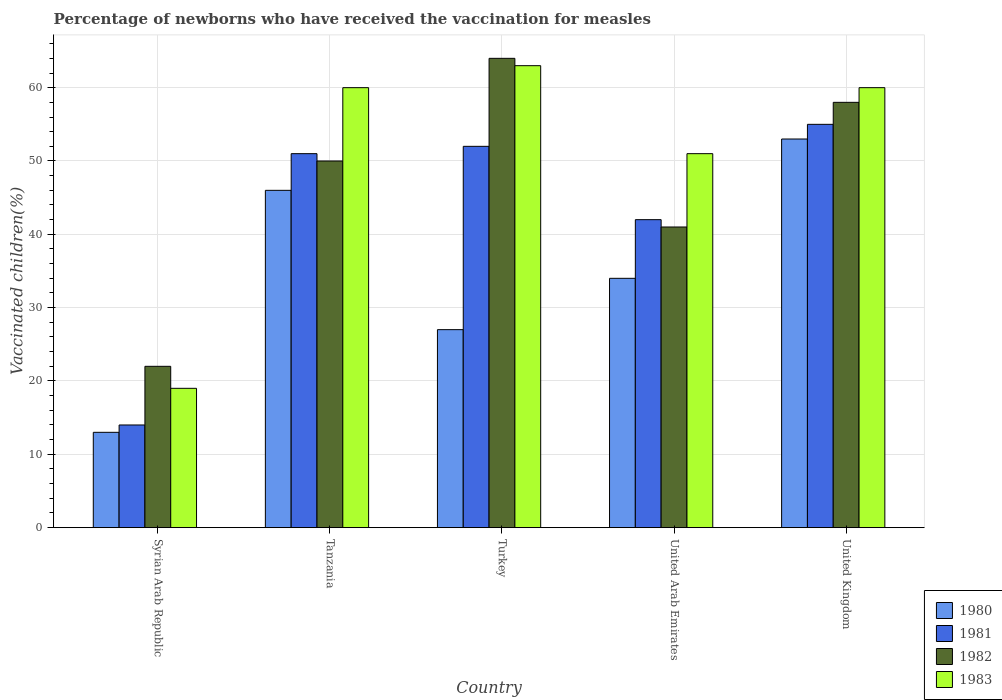How many groups of bars are there?
Make the answer very short. 5. Are the number of bars on each tick of the X-axis equal?
Provide a short and direct response. Yes. How many bars are there on the 3rd tick from the left?
Provide a succinct answer. 4. How many bars are there on the 4th tick from the right?
Your answer should be very brief. 4. What is the label of the 2nd group of bars from the left?
Your answer should be very brief. Tanzania. What is the percentage of vaccinated children in 1982 in Tanzania?
Offer a very short reply. 50. Across all countries, what is the maximum percentage of vaccinated children in 1983?
Keep it short and to the point. 63. Across all countries, what is the minimum percentage of vaccinated children in 1983?
Ensure brevity in your answer.  19. In which country was the percentage of vaccinated children in 1980 minimum?
Offer a very short reply. Syrian Arab Republic. What is the total percentage of vaccinated children in 1983 in the graph?
Ensure brevity in your answer.  253. What is the difference between the percentage of vaccinated children in 1981 in Tanzania and that in Turkey?
Your response must be concise. -1. What is the average percentage of vaccinated children in 1980 per country?
Ensure brevity in your answer.  34.6. What is the difference between the percentage of vaccinated children of/in 1983 and percentage of vaccinated children of/in 1980 in United Arab Emirates?
Offer a very short reply. 17. What is the ratio of the percentage of vaccinated children in 1981 in Syrian Arab Republic to that in Turkey?
Make the answer very short. 0.27. What is the difference between the highest and the lowest percentage of vaccinated children in 1983?
Provide a succinct answer. 44. Is the sum of the percentage of vaccinated children in 1982 in Tanzania and Turkey greater than the maximum percentage of vaccinated children in 1983 across all countries?
Provide a succinct answer. Yes. Is it the case that in every country, the sum of the percentage of vaccinated children in 1982 and percentage of vaccinated children in 1980 is greater than the sum of percentage of vaccinated children in 1981 and percentage of vaccinated children in 1983?
Ensure brevity in your answer.  No. What does the 2nd bar from the left in United Kingdom represents?
Offer a very short reply. 1981. What does the 2nd bar from the right in United Arab Emirates represents?
Your answer should be compact. 1982. Is it the case that in every country, the sum of the percentage of vaccinated children in 1983 and percentage of vaccinated children in 1982 is greater than the percentage of vaccinated children in 1981?
Offer a very short reply. Yes. Are all the bars in the graph horizontal?
Make the answer very short. No. Does the graph contain grids?
Provide a succinct answer. Yes. Where does the legend appear in the graph?
Your answer should be very brief. Bottom right. How many legend labels are there?
Your answer should be very brief. 4. What is the title of the graph?
Provide a short and direct response. Percentage of newborns who have received the vaccination for measles. Does "1960" appear as one of the legend labels in the graph?
Give a very brief answer. No. What is the label or title of the X-axis?
Your response must be concise. Country. What is the label or title of the Y-axis?
Make the answer very short. Vaccinated children(%). What is the Vaccinated children(%) of 1981 in Tanzania?
Offer a terse response. 51. What is the Vaccinated children(%) of 1982 in Tanzania?
Offer a terse response. 50. What is the Vaccinated children(%) in 1980 in Turkey?
Your response must be concise. 27. What is the Vaccinated children(%) of 1982 in Turkey?
Ensure brevity in your answer.  64. What is the Vaccinated children(%) of 1983 in Turkey?
Keep it short and to the point. 63. What is the Vaccinated children(%) of 1980 in United Arab Emirates?
Provide a short and direct response. 34. What is the Vaccinated children(%) in 1981 in United Arab Emirates?
Your answer should be compact. 42. What is the Vaccinated children(%) in 1980 in United Kingdom?
Offer a very short reply. 53. Across all countries, what is the maximum Vaccinated children(%) in 1980?
Keep it short and to the point. 53. Across all countries, what is the maximum Vaccinated children(%) of 1981?
Make the answer very short. 55. Across all countries, what is the maximum Vaccinated children(%) of 1982?
Your answer should be very brief. 64. Across all countries, what is the maximum Vaccinated children(%) in 1983?
Keep it short and to the point. 63. Across all countries, what is the minimum Vaccinated children(%) in 1982?
Your answer should be compact. 22. Across all countries, what is the minimum Vaccinated children(%) of 1983?
Offer a very short reply. 19. What is the total Vaccinated children(%) in 1980 in the graph?
Keep it short and to the point. 173. What is the total Vaccinated children(%) in 1981 in the graph?
Keep it short and to the point. 214. What is the total Vaccinated children(%) of 1982 in the graph?
Offer a terse response. 235. What is the total Vaccinated children(%) in 1983 in the graph?
Your answer should be compact. 253. What is the difference between the Vaccinated children(%) in 1980 in Syrian Arab Republic and that in Tanzania?
Make the answer very short. -33. What is the difference between the Vaccinated children(%) of 1981 in Syrian Arab Republic and that in Tanzania?
Your answer should be compact. -37. What is the difference between the Vaccinated children(%) of 1982 in Syrian Arab Republic and that in Tanzania?
Give a very brief answer. -28. What is the difference between the Vaccinated children(%) of 1983 in Syrian Arab Republic and that in Tanzania?
Keep it short and to the point. -41. What is the difference between the Vaccinated children(%) of 1980 in Syrian Arab Republic and that in Turkey?
Provide a succinct answer. -14. What is the difference between the Vaccinated children(%) of 1981 in Syrian Arab Republic and that in Turkey?
Make the answer very short. -38. What is the difference between the Vaccinated children(%) of 1982 in Syrian Arab Republic and that in Turkey?
Your answer should be compact. -42. What is the difference between the Vaccinated children(%) in 1983 in Syrian Arab Republic and that in Turkey?
Keep it short and to the point. -44. What is the difference between the Vaccinated children(%) in 1980 in Syrian Arab Republic and that in United Arab Emirates?
Offer a very short reply. -21. What is the difference between the Vaccinated children(%) in 1982 in Syrian Arab Republic and that in United Arab Emirates?
Give a very brief answer. -19. What is the difference between the Vaccinated children(%) in 1983 in Syrian Arab Republic and that in United Arab Emirates?
Provide a short and direct response. -32. What is the difference between the Vaccinated children(%) in 1980 in Syrian Arab Republic and that in United Kingdom?
Give a very brief answer. -40. What is the difference between the Vaccinated children(%) of 1981 in Syrian Arab Republic and that in United Kingdom?
Offer a terse response. -41. What is the difference between the Vaccinated children(%) of 1982 in Syrian Arab Republic and that in United Kingdom?
Offer a terse response. -36. What is the difference between the Vaccinated children(%) of 1983 in Syrian Arab Republic and that in United Kingdom?
Ensure brevity in your answer.  -41. What is the difference between the Vaccinated children(%) in 1980 in Tanzania and that in Turkey?
Keep it short and to the point. 19. What is the difference between the Vaccinated children(%) of 1981 in Tanzania and that in Turkey?
Provide a succinct answer. -1. What is the difference between the Vaccinated children(%) of 1982 in Tanzania and that in Turkey?
Provide a succinct answer. -14. What is the difference between the Vaccinated children(%) in 1983 in Tanzania and that in Turkey?
Make the answer very short. -3. What is the difference between the Vaccinated children(%) in 1982 in Tanzania and that in United Arab Emirates?
Give a very brief answer. 9. What is the difference between the Vaccinated children(%) in 1983 in Tanzania and that in United Arab Emirates?
Your answer should be very brief. 9. What is the difference between the Vaccinated children(%) of 1981 in Tanzania and that in United Kingdom?
Give a very brief answer. -4. What is the difference between the Vaccinated children(%) in 1983 in Tanzania and that in United Kingdom?
Ensure brevity in your answer.  0. What is the difference between the Vaccinated children(%) in 1983 in Turkey and that in United Arab Emirates?
Your response must be concise. 12. What is the difference between the Vaccinated children(%) in 1980 in United Arab Emirates and that in United Kingdom?
Provide a short and direct response. -19. What is the difference between the Vaccinated children(%) in 1981 in United Arab Emirates and that in United Kingdom?
Your response must be concise. -13. What is the difference between the Vaccinated children(%) of 1982 in United Arab Emirates and that in United Kingdom?
Your answer should be compact. -17. What is the difference between the Vaccinated children(%) of 1980 in Syrian Arab Republic and the Vaccinated children(%) of 1981 in Tanzania?
Make the answer very short. -38. What is the difference between the Vaccinated children(%) of 1980 in Syrian Arab Republic and the Vaccinated children(%) of 1982 in Tanzania?
Your response must be concise. -37. What is the difference between the Vaccinated children(%) in 1980 in Syrian Arab Republic and the Vaccinated children(%) in 1983 in Tanzania?
Offer a very short reply. -47. What is the difference between the Vaccinated children(%) in 1981 in Syrian Arab Republic and the Vaccinated children(%) in 1982 in Tanzania?
Ensure brevity in your answer.  -36. What is the difference between the Vaccinated children(%) in 1981 in Syrian Arab Republic and the Vaccinated children(%) in 1983 in Tanzania?
Provide a succinct answer. -46. What is the difference between the Vaccinated children(%) in 1982 in Syrian Arab Republic and the Vaccinated children(%) in 1983 in Tanzania?
Keep it short and to the point. -38. What is the difference between the Vaccinated children(%) in 1980 in Syrian Arab Republic and the Vaccinated children(%) in 1981 in Turkey?
Provide a succinct answer. -39. What is the difference between the Vaccinated children(%) of 1980 in Syrian Arab Republic and the Vaccinated children(%) of 1982 in Turkey?
Keep it short and to the point. -51. What is the difference between the Vaccinated children(%) in 1981 in Syrian Arab Republic and the Vaccinated children(%) in 1982 in Turkey?
Keep it short and to the point. -50. What is the difference between the Vaccinated children(%) in 1981 in Syrian Arab Republic and the Vaccinated children(%) in 1983 in Turkey?
Provide a short and direct response. -49. What is the difference between the Vaccinated children(%) in 1982 in Syrian Arab Republic and the Vaccinated children(%) in 1983 in Turkey?
Your response must be concise. -41. What is the difference between the Vaccinated children(%) in 1980 in Syrian Arab Republic and the Vaccinated children(%) in 1981 in United Arab Emirates?
Your answer should be very brief. -29. What is the difference between the Vaccinated children(%) in 1980 in Syrian Arab Republic and the Vaccinated children(%) in 1983 in United Arab Emirates?
Ensure brevity in your answer.  -38. What is the difference between the Vaccinated children(%) in 1981 in Syrian Arab Republic and the Vaccinated children(%) in 1983 in United Arab Emirates?
Provide a short and direct response. -37. What is the difference between the Vaccinated children(%) in 1982 in Syrian Arab Republic and the Vaccinated children(%) in 1983 in United Arab Emirates?
Offer a very short reply. -29. What is the difference between the Vaccinated children(%) in 1980 in Syrian Arab Republic and the Vaccinated children(%) in 1981 in United Kingdom?
Offer a very short reply. -42. What is the difference between the Vaccinated children(%) of 1980 in Syrian Arab Republic and the Vaccinated children(%) of 1982 in United Kingdom?
Keep it short and to the point. -45. What is the difference between the Vaccinated children(%) in 1980 in Syrian Arab Republic and the Vaccinated children(%) in 1983 in United Kingdom?
Keep it short and to the point. -47. What is the difference between the Vaccinated children(%) of 1981 in Syrian Arab Republic and the Vaccinated children(%) of 1982 in United Kingdom?
Offer a very short reply. -44. What is the difference between the Vaccinated children(%) of 1981 in Syrian Arab Republic and the Vaccinated children(%) of 1983 in United Kingdom?
Make the answer very short. -46. What is the difference between the Vaccinated children(%) in 1982 in Syrian Arab Republic and the Vaccinated children(%) in 1983 in United Kingdom?
Offer a terse response. -38. What is the difference between the Vaccinated children(%) of 1980 in Tanzania and the Vaccinated children(%) of 1982 in Turkey?
Your answer should be very brief. -18. What is the difference between the Vaccinated children(%) of 1980 in Tanzania and the Vaccinated children(%) of 1983 in Turkey?
Your response must be concise. -17. What is the difference between the Vaccinated children(%) of 1982 in Tanzania and the Vaccinated children(%) of 1983 in Turkey?
Your response must be concise. -13. What is the difference between the Vaccinated children(%) in 1980 in Tanzania and the Vaccinated children(%) in 1982 in United Arab Emirates?
Make the answer very short. 5. What is the difference between the Vaccinated children(%) of 1981 in Tanzania and the Vaccinated children(%) of 1982 in United Arab Emirates?
Give a very brief answer. 10. What is the difference between the Vaccinated children(%) of 1981 in Tanzania and the Vaccinated children(%) of 1983 in United Arab Emirates?
Make the answer very short. 0. What is the difference between the Vaccinated children(%) in 1982 in Tanzania and the Vaccinated children(%) in 1983 in United Arab Emirates?
Your answer should be very brief. -1. What is the difference between the Vaccinated children(%) in 1980 in Tanzania and the Vaccinated children(%) in 1981 in United Kingdom?
Offer a very short reply. -9. What is the difference between the Vaccinated children(%) of 1980 in Tanzania and the Vaccinated children(%) of 1982 in United Kingdom?
Provide a short and direct response. -12. What is the difference between the Vaccinated children(%) in 1980 in Turkey and the Vaccinated children(%) in 1981 in United Arab Emirates?
Provide a short and direct response. -15. What is the difference between the Vaccinated children(%) in 1980 in Turkey and the Vaccinated children(%) in 1983 in United Arab Emirates?
Your answer should be compact. -24. What is the difference between the Vaccinated children(%) in 1981 in Turkey and the Vaccinated children(%) in 1983 in United Arab Emirates?
Offer a terse response. 1. What is the difference between the Vaccinated children(%) in 1982 in Turkey and the Vaccinated children(%) in 1983 in United Arab Emirates?
Provide a short and direct response. 13. What is the difference between the Vaccinated children(%) in 1980 in Turkey and the Vaccinated children(%) in 1982 in United Kingdom?
Offer a terse response. -31. What is the difference between the Vaccinated children(%) in 1980 in Turkey and the Vaccinated children(%) in 1983 in United Kingdom?
Your response must be concise. -33. What is the difference between the Vaccinated children(%) of 1982 in Turkey and the Vaccinated children(%) of 1983 in United Kingdom?
Your answer should be very brief. 4. What is the difference between the Vaccinated children(%) of 1980 in United Arab Emirates and the Vaccinated children(%) of 1982 in United Kingdom?
Ensure brevity in your answer.  -24. What is the difference between the Vaccinated children(%) in 1981 in United Arab Emirates and the Vaccinated children(%) in 1982 in United Kingdom?
Keep it short and to the point. -16. What is the difference between the Vaccinated children(%) of 1981 in United Arab Emirates and the Vaccinated children(%) of 1983 in United Kingdom?
Ensure brevity in your answer.  -18. What is the difference between the Vaccinated children(%) in 1982 in United Arab Emirates and the Vaccinated children(%) in 1983 in United Kingdom?
Ensure brevity in your answer.  -19. What is the average Vaccinated children(%) of 1980 per country?
Offer a terse response. 34.6. What is the average Vaccinated children(%) of 1981 per country?
Offer a very short reply. 42.8. What is the average Vaccinated children(%) of 1982 per country?
Provide a succinct answer. 47. What is the average Vaccinated children(%) of 1983 per country?
Offer a terse response. 50.6. What is the difference between the Vaccinated children(%) of 1980 and Vaccinated children(%) of 1983 in Syrian Arab Republic?
Keep it short and to the point. -6. What is the difference between the Vaccinated children(%) of 1981 and Vaccinated children(%) of 1982 in Syrian Arab Republic?
Your answer should be very brief. -8. What is the difference between the Vaccinated children(%) in 1981 and Vaccinated children(%) in 1983 in Syrian Arab Republic?
Provide a succinct answer. -5. What is the difference between the Vaccinated children(%) of 1982 and Vaccinated children(%) of 1983 in Syrian Arab Republic?
Give a very brief answer. 3. What is the difference between the Vaccinated children(%) of 1980 and Vaccinated children(%) of 1981 in Tanzania?
Provide a succinct answer. -5. What is the difference between the Vaccinated children(%) in 1980 and Vaccinated children(%) in 1982 in Tanzania?
Your answer should be compact. -4. What is the difference between the Vaccinated children(%) in 1980 and Vaccinated children(%) in 1983 in Tanzania?
Provide a succinct answer. -14. What is the difference between the Vaccinated children(%) of 1981 and Vaccinated children(%) of 1983 in Tanzania?
Provide a short and direct response. -9. What is the difference between the Vaccinated children(%) in 1980 and Vaccinated children(%) in 1981 in Turkey?
Keep it short and to the point. -25. What is the difference between the Vaccinated children(%) of 1980 and Vaccinated children(%) of 1982 in Turkey?
Give a very brief answer. -37. What is the difference between the Vaccinated children(%) in 1980 and Vaccinated children(%) in 1983 in Turkey?
Ensure brevity in your answer.  -36. What is the difference between the Vaccinated children(%) of 1982 and Vaccinated children(%) of 1983 in Turkey?
Make the answer very short. 1. What is the difference between the Vaccinated children(%) of 1981 and Vaccinated children(%) of 1982 in United Arab Emirates?
Offer a very short reply. 1. What is the difference between the Vaccinated children(%) in 1980 and Vaccinated children(%) in 1981 in United Kingdom?
Your answer should be compact. -2. What is the difference between the Vaccinated children(%) of 1980 and Vaccinated children(%) of 1983 in United Kingdom?
Ensure brevity in your answer.  -7. What is the difference between the Vaccinated children(%) of 1981 and Vaccinated children(%) of 1982 in United Kingdom?
Provide a short and direct response. -3. What is the difference between the Vaccinated children(%) in 1981 and Vaccinated children(%) in 1983 in United Kingdom?
Ensure brevity in your answer.  -5. What is the ratio of the Vaccinated children(%) in 1980 in Syrian Arab Republic to that in Tanzania?
Your answer should be compact. 0.28. What is the ratio of the Vaccinated children(%) in 1981 in Syrian Arab Republic to that in Tanzania?
Your answer should be very brief. 0.27. What is the ratio of the Vaccinated children(%) in 1982 in Syrian Arab Republic to that in Tanzania?
Your answer should be compact. 0.44. What is the ratio of the Vaccinated children(%) of 1983 in Syrian Arab Republic to that in Tanzania?
Give a very brief answer. 0.32. What is the ratio of the Vaccinated children(%) in 1980 in Syrian Arab Republic to that in Turkey?
Offer a very short reply. 0.48. What is the ratio of the Vaccinated children(%) of 1981 in Syrian Arab Republic to that in Turkey?
Your response must be concise. 0.27. What is the ratio of the Vaccinated children(%) in 1982 in Syrian Arab Republic to that in Turkey?
Keep it short and to the point. 0.34. What is the ratio of the Vaccinated children(%) in 1983 in Syrian Arab Republic to that in Turkey?
Your answer should be very brief. 0.3. What is the ratio of the Vaccinated children(%) in 1980 in Syrian Arab Republic to that in United Arab Emirates?
Offer a terse response. 0.38. What is the ratio of the Vaccinated children(%) in 1982 in Syrian Arab Republic to that in United Arab Emirates?
Provide a succinct answer. 0.54. What is the ratio of the Vaccinated children(%) of 1983 in Syrian Arab Republic to that in United Arab Emirates?
Make the answer very short. 0.37. What is the ratio of the Vaccinated children(%) in 1980 in Syrian Arab Republic to that in United Kingdom?
Provide a short and direct response. 0.25. What is the ratio of the Vaccinated children(%) of 1981 in Syrian Arab Republic to that in United Kingdom?
Your answer should be very brief. 0.25. What is the ratio of the Vaccinated children(%) in 1982 in Syrian Arab Republic to that in United Kingdom?
Keep it short and to the point. 0.38. What is the ratio of the Vaccinated children(%) of 1983 in Syrian Arab Republic to that in United Kingdom?
Your answer should be very brief. 0.32. What is the ratio of the Vaccinated children(%) of 1980 in Tanzania to that in Turkey?
Provide a short and direct response. 1.7. What is the ratio of the Vaccinated children(%) in 1981 in Tanzania to that in Turkey?
Your response must be concise. 0.98. What is the ratio of the Vaccinated children(%) in 1982 in Tanzania to that in Turkey?
Ensure brevity in your answer.  0.78. What is the ratio of the Vaccinated children(%) in 1980 in Tanzania to that in United Arab Emirates?
Give a very brief answer. 1.35. What is the ratio of the Vaccinated children(%) of 1981 in Tanzania to that in United Arab Emirates?
Provide a short and direct response. 1.21. What is the ratio of the Vaccinated children(%) of 1982 in Tanzania to that in United Arab Emirates?
Offer a very short reply. 1.22. What is the ratio of the Vaccinated children(%) of 1983 in Tanzania to that in United Arab Emirates?
Offer a very short reply. 1.18. What is the ratio of the Vaccinated children(%) of 1980 in Tanzania to that in United Kingdom?
Provide a succinct answer. 0.87. What is the ratio of the Vaccinated children(%) in 1981 in Tanzania to that in United Kingdom?
Keep it short and to the point. 0.93. What is the ratio of the Vaccinated children(%) in 1982 in Tanzania to that in United Kingdom?
Ensure brevity in your answer.  0.86. What is the ratio of the Vaccinated children(%) of 1980 in Turkey to that in United Arab Emirates?
Your answer should be very brief. 0.79. What is the ratio of the Vaccinated children(%) in 1981 in Turkey to that in United Arab Emirates?
Give a very brief answer. 1.24. What is the ratio of the Vaccinated children(%) in 1982 in Turkey to that in United Arab Emirates?
Your answer should be very brief. 1.56. What is the ratio of the Vaccinated children(%) in 1983 in Turkey to that in United Arab Emirates?
Offer a very short reply. 1.24. What is the ratio of the Vaccinated children(%) in 1980 in Turkey to that in United Kingdom?
Make the answer very short. 0.51. What is the ratio of the Vaccinated children(%) of 1981 in Turkey to that in United Kingdom?
Provide a succinct answer. 0.95. What is the ratio of the Vaccinated children(%) in 1982 in Turkey to that in United Kingdom?
Your answer should be very brief. 1.1. What is the ratio of the Vaccinated children(%) in 1980 in United Arab Emirates to that in United Kingdom?
Make the answer very short. 0.64. What is the ratio of the Vaccinated children(%) in 1981 in United Arab Emirates to that in United Kingdom?
Make the answer very short. 0.76. What is the ratio of the Vaccinated children(%) of 1982 in United Arab Emirates to that in United Kingdom?
Offer a very short reply. 0.71. What is the difference between the highest and the second highest Vaccinated children(%) of 1981?
Your answer should be very brief. 3. What is the difference between the highest and the lowest Vaccinated children(%) of 1980?
Your response must be concise. 40. 